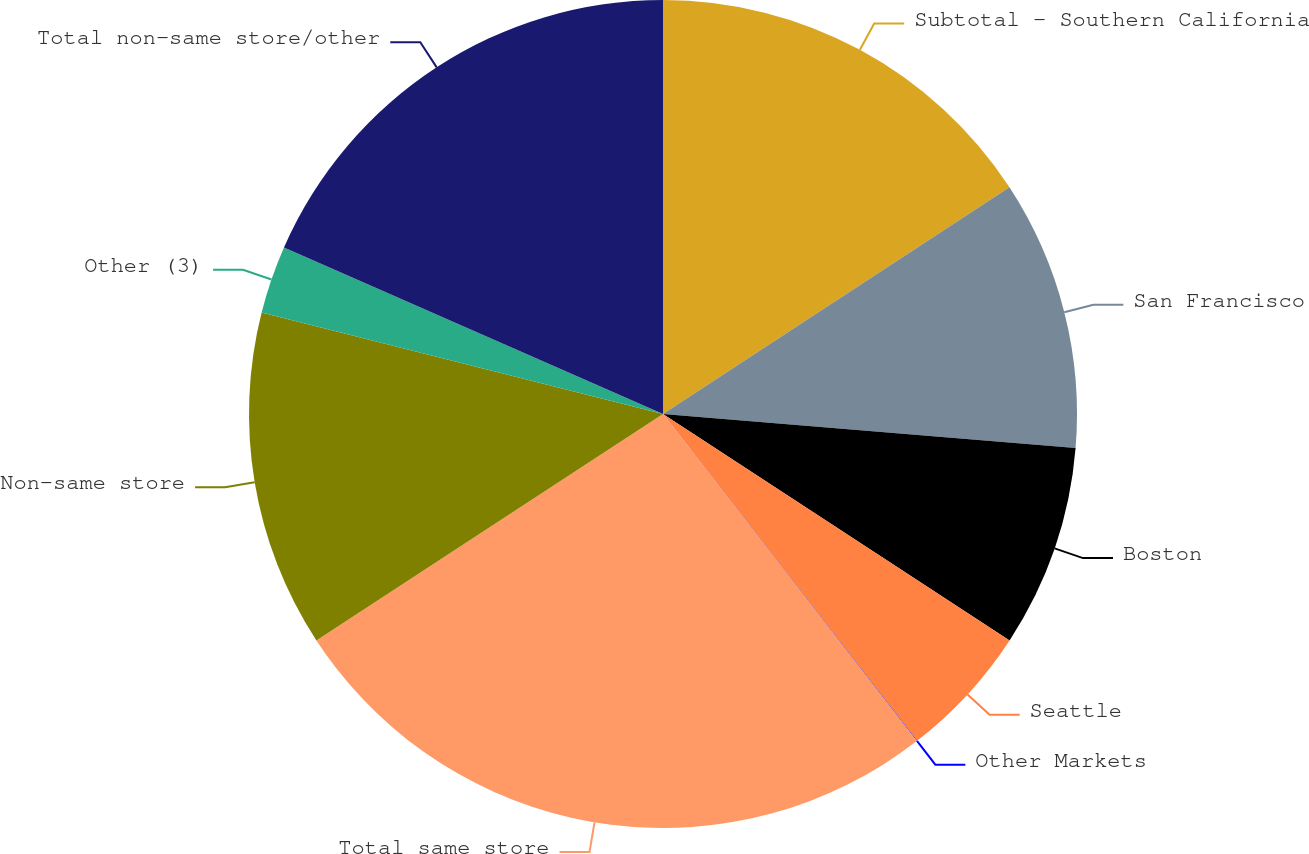Convert chart to OTSL. <chart><loc_0><loc_0><loc_500><loc_500><pie_chart><fcel>Subtotal - Southern California<fcel>San Francisco<fcel>Boston<fcel>Seattle<fcel>Other Markets<fcel>Total same store<fcel>Non-same store<fcel>Other (3)<fcel>Total non-same store/other<nl><fcel>15.78%<fcel>10.53%<fcel>7.9%<fcel>5.27%<fcel>0.02%<fcel>26.29%<fcel>13.15%<fcel>2.65%<fcel>18.41%<nl></chart> 